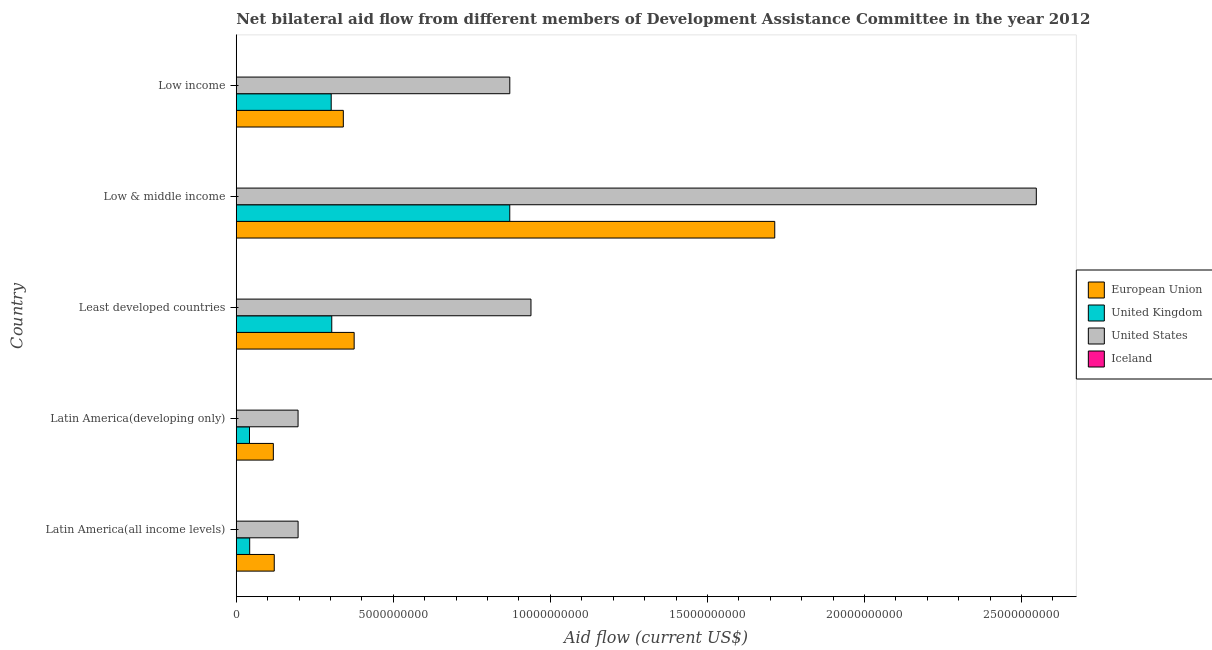How many different coloured bars are there?
Your answer should be very brief. 4. How many groups of bars are there?
Make the answer very short. 5. What is the label of the 4th group of bars from the top?
Provide a succinct answer. Latin America(developing only). In how many cases, is the number of bars for a given country not equal to the number of legend labels?
Give a very brief answer. 0. What is the amount of aid given by eu in Low income?
Make the answer very short. 3.41e+09. Across all countries, what is the maximum amount of aid given by iceland?
Offer a terse response. 2.04e+06. Across all countries, what is the minimum amount of aid given by us?
Keep it short and to the point. 1.97e+09. In which country was the amount of aid given by us maximum?
Your response must be concise. Low & middle income. In which country was the amount of aid given by us minimum?
Provide a succinct answer. Latin America(developing only). What is the total amount of aid given by eu in the graph?
Make the answer very short. 2.67e+1. What is the difference between the amount of aid given by uk in Latin America(developing only) and that in Least developed countries?
Provide a succinct answer. -2.62e+09. What is the difference between the amount of aid given by iceland in Latin America(all income levels) and the amount of aid given by us in Low income?
Your response must be concise. -8.71e+09. What is the average amount of aid given by iceland per country?
Your answer should be compact. 9.96e+05. What is the difference between the amount of aid given by iceland and amount of aid given by us in Low & middle income?
Keep it short and to the point. -2.55e+1. What is the ratio of the amount of aid given by us in Low & middle income to that in Low income?
Make the answer very short. 2.92. Is the difference between the amount of aid given by us in Latin America(developing only) and Least developed countries greater than the difference between the amount of aid given by eu in Latin America(developing only) and Least developed countries?
Provide a short and direct response. No. What is the difference between the highest and the second highest amount of aid given by uk?
Your response must be concise. 5.67e+09. What is the difference between the highest and the lowest amount of aid given by iceland?
Make the answer very short. 1.94e+06. What does the 1st bar from the top in Least developed countries represents?
Your response must be concise. Iceland. How many bars are there?
Offer a terse response. 20. Are all the bars in the graph horizontal?
Your answer should be very brief. Yes. What is the difference between two consecutive major ticks on the X-axis?
Provide a succinct answer. 5.00e+09. How many legend labels are there?
Your answer should be very brief. 4. What is the title of the graph?
Offer a very short reply. Net bilateral aid flow from different members of Development Assistance Committee in the year 2012. What is the label or title of the X-axis?
Provide a succinct answer. Aid flow (current US$). What is the Aid flow (current US$) of European Union in Latin America(all income levels)?
Your answer should be compact. 1.21e+09. What is the Aid flow (current US$) of United Kingdom in Latin America(all income levels)?
Your response must be concise. 4.28e+08. What is the Aid flow (current US$) in United States in Latin America(all income levels)?
Provide a succinct answer. 1.97e+09. What is the Aid flow (current US$) of Iceland in Latin America(all income levels)?
Offer a terse response. 1.37e+06. What is the Aid flow (current US$) of European Union in Latin America(developing only)?
Ensure brevity in your answer.  1.18e+09. What is the Aid flow (current US$) of United Kingdom in Latin America(developing only)?
Keep it short and to the point. 4.22e+08. What is the Aid flow (current US$) of United States in Latin America(developing only)?
Give a very brief answer. 1.97e+09. What is the Aid flow (current US$) in Iceland in Latin America(developing only)?
Offer a very short reply. 1.37e+06. What is the Aid flow (current US$) of European Union in Least developed countries?
Give a very brief answer. 3.75e+09. What is the Aid flow (current US$) of United Kingdom in Least developed countries?
Give a very brief answer. 3.04e+09. What is the Aid flow (current US$) in United States in Least developed countries?
Keep it short and to the point. 9.38e+09. What is the Aid flow (current US$) of Iceland in Least developed countries?
Make the answer very short. 2.04e+06. What is the Aid flow (current US$) of European Union in Low & middle income?
Keep it short and to the point. 1.71e+1. What is the Aid flow (current US$) of United Kingdom in Low & middle income?
Your answer should be very brief. 8.71e+09. What is the Aid flow (current US$) of United States in Low & middle income?
Ensure brevity in your answer.  2.55e+1. What is the Aid flow (current US$) of Iceland in Low & middle income?
Ensure brevity in your answer.  1.00e+05. What is the Aid flow (current US$) in European Union in Low income?
Offer a very short reply. 3.41e+09. What is the Aid flow (current US$) in United Kingdom in Low income?
Provide a succinct answer. 3.02e+09. What is the Aid flow (current US$) of United States in Low income?
Ensure brevity in your answer.  8.71e+09. Across all countries, what is the maximum Aid flow (current US$) in European Union?
Provide a short and direct response. 1.71e+1. Across all countries, what is the maximum Aid flow (current US$) in United Kingdom?
Keep it short and to the point. 8.71e+09. Across all countries, what is the maximum Aid flow (current US$) of United States?
Your response must be concise. 2.55e+1. Across all countries, what is the maximum Aid flow (current US$) in Iceland?
Provide a short and direct response. 2.04e+06. Across all countries, what is the minimum Aid flow (current US$) in European Union?
Offer a terse response. 1.18e+09. Across all countries, what is the minimum Aid flow (current US$) of United Kingdom?
Ensure brevity in your answer.  4.22e+08. Across all countries, what is the minimum Aid flow (current US$) in United States?
Ensure brevity in your answer.  1.97e+09. Across all countries, what is the minimum Aid flow (current US$) in Iceland?
Your response must be concise. 1.00e+05. What is the total Aid flow (current US$) in European Union in the graph?
Keep it short and to the point. 2.67e+1. What is the total Aid flow (current US$) of United Kingdom in the graph?
Make the answer very short. 1.56e+1. What is the total Aid flow (current US$) of United States in the graph?
Offer a terse response. 4.75e+1. What is the total Aid flow (current US$) in Iceland in the graph?
Ensure brevity in your answer.  4.98e+06. What is the difference between the Aid flow (current US$) in European Union in Latin America(all income levels) and that in Latin America(developing only)?
Your response must be concise. 2.92e+07. What is the difference between the Aid flow (current US$) of United Kingdom in Latin America(all income levels) and that in Latin America(developing only)?
Your answer should be compact. 5.89e+06. What is the difference between the Aid flow (current US$) in United States in Latin America(all income levels) and that in Latin America(developing only)?
Offer a terse response. 1.03e+06. What is the difference between the Aid flow (current US$) of European Union in Latin America(all income levels) and that in Least developed countries?
Your answer should be compact. -2.54e+09. What is the difference between the Aid flow (current US$) of United Kingdom in Latin America(all income levels) and that in Least developed countries?
Offer a very short reply. -2.61e+09. What is the difference between the Aid flow (current US$) of United States in Latin America(all income levels) and that in Least developed countries?
Your answer should be very brief. -7.41e+09. What is the difference between the Aid flow (current US$) of Iceland in Latin America(all income levels) and that in Least developed countries?
Keep it short and to the point. -6.70e+05. What is the difference between the Aid flow (current US$) in European Union in Latin America(all income levels) and that in Low & middle income?
Keep it short and to the point. -1.59e+1. What is the difference between the Aid flow (current US$) of United Kingdom in Latin America(all income levels) and that in Low & middle income?
Give a very brief answer. -8.28e+09. What is the difference between the Aid flow (current US$) in United States in Latin America(all income levels) and that in Low & middle income?
Give a very brief answer. -2.35e+1. What is the difference between the Aid flow (current US$) of Iceland in Latin America(all income levels) and that in Low & middle income?
Your response must be concise. 1.27e+06. What is the difference between the Aid flow (current US$) of European Union in Latin America(all income levels) and that in Low income?
Offer a very short reply. -2.20e+09. What is the difference between the Aid flow (current US$) in United Kingdom in Latin America(all income levels) and that in Low income?
Offer a terse response. -2.60e+09. What is the difference between the Aid flow (current US$) in United States in Latin America(all income levels) and that in Low income?
Provide a succinct answer. -6.74e+09. What is the difference between the Aid flow (current US$) in Iceland in Latin America(all income levels) and that in Low income?
Provide a short and direct response. 1.27e+06. What is the difference between the Aid flow (current US$) in European Union in Latin America(developing only) and that in Least developed countries?
Keep it short and to the point. -2.57e+09. What is the difference between the Aid flow (current US$) in United Kingdom in Latin America(developing only) and that in Least developed countries?
Your answer should be compact. -2.62e+09. What is the difference between the Aid flow (current US$) in United States in Latin America(developing only) and that in Least developed countries?
Make the answer very short. -7.41e+09. What is the difference between the Aid flow (current US$) in Iceland in Latin America(developing only) and that in Least developed countries?
Your answer should be very brief. -6.70e+05. What is the difference between the Aid flow (current US$) of European Union in Latin America(developing only) and that in Low & middle income?
Provide a short and direct response. -1.60e+1. What is the difference between the Aid flow (current US$) of United Kingdom in Latin America(developing only) and that in Low & middle income?
Your response must be concise. -8.29e+09. What is the difference between the Aid flow (current US$) in United States in Latin America(developing only) and that in Low & middle income?
Provide a succinct answer. -2.35e+1. What is the difference between the Aid flow (current US$) of Iceland in Latin America(developing only) and that in Low & middle income?
Your answer should be very brief. 1.27e+06. What is the difference between the Aid flow (current US$) of European Union in Latin America(developing only) and that in Low income?
Your answer should be very brief. -2.23e+09. What is the difference between the Aid flow (current US$) in United Kingdom in Latin America(developing only) and that in Low income?
Offer a very short reply. -2.60e+09. What is the difference between the Aid flow (current US$) of United States in Latin America(developing only) and that in Low income?
Offer a very short reply. -6.74e+09. What is the difference between the Aid flow (current US$) in Iceland in Latin America(developing only) and that in Low income?
Provide a short and direct response. 1.27e+06. What is the difference between the Aid flow (current US$) of European Union in Least developed countries and that in Low & middle income?
Your answer should be compact. -1.34e+1. What is the difference between the Aid flow (current US$) in United Kingdom in Least developed countries and that in Low & middle income?
Ensure brevity in your answer.  -5.67e+09. What is the difference between the Aid flow (current US$) of United States in Least developed countries and that in Low & middle income?
Make the answer very short. -1.61e+1. What is the difference between the Aid flow (current US$) in Iceland in Least developed countries and that in Low & middle income?
Make the answer very short. 1.94e+06. What is the difference between the Aid flow (current US$) in European Union in Least developed countries and that in Low income?
Ensure brevity in your answer.  3.45e+08. What is the difference between the Aid flow (current US$) of United Kingdom in Least developed countries and that in Low income?
Offer a terse response. 1.79e+07. What is the difference between the Aid flow (current US$) of United States in Least developed countries and that in Low income?
Your answer should be compact. 6.74e+08. What is the difference between the Aid flow (current US$) of Iceland in Least developed countries and that in Low income?
Your answer should be very brief. 1.94e+06. What is the difference between the Aid flow (current US$) in European Union in Low & middle income and that in Low income?
Your response must be concise. 1.37e+1. What is the difference between the Aid flow (current US$) in United Kingdom in Low & middle income and that in Low income?
Make the answer very short. 5.68e+09. What is the difference between the Aid flow (current US$) of United States in Low & middle income and that in Low income?
Provide a succinct answer. 1.68e+1. What is the difference between the Aid flow (current US$) of Iceland in Low & middle income and that in Low income?
Give a very brief answer. 0. What is the difference between the Aid flow (current US$) in European Union in Latin America(all income levels) and the Aid flow (current US$) in United Kingdom in Latin America(developing only)?
Offer a terse response. 7.88e+08. What is the difference between the Aid flow (current US$) of European Union in Latin America(all income levels) and the Aid flow (current US$) of United States in Latin America(developing only)?
Ensure brevity in your answer.  -7.58e+08. What is the difference between the Aid flow (current US$) of European Union in Latin America(all income levels) and the Aid flow (current US$) of Iceland in Latin America(developing only)?
Give a very brief answer. 1.21e+09. What is the difference between the Aid flow (current US$) in United Kingdom in Latin America(all income levels) and the Aid flow (current US$) in United States in Latin America(developing only)?
Offer a terse response. -1.54e+09. What is the difference between the Aid flow (current US$) in United Kingdom in Latin America(all income levels) and the Aid flow (current US$) in Iceland in Latin America(developing only)?
Give a very brief answer. 4.26e+08. What is the difference between the Aid flow (current US$) of United States in Latin America(all income levels) and the Aid flow (current US$) of Iceland in Latin America(developing only)?
Make the answer very short. 1.97e+09. What is the difference between the Aid flow (current US$) in European Union in Latin America(all income levels) and the Aid flow (current US$) in United Kingdom in Least developed countries?
Offer a terse response. -1.83e+09. What is the difference between the Aid flow (current US$) of European Union in Latin America(all income levels) and the Aid flow (current US$) of United States in Least developed countries?
Your answer should be compact. -8.17e+09. What is the difference between the Aid flow (current US$) in European Union in Latin America(all income levels) and the Aid flow (current US$) in Iceland in Least developed countries?
Ensure brevity in your answer.  1.21e+09. What is the difference between the Aid flow (current US$) of United Kingdom in Latin America(all income levels) and the Aid flow (current US$) of United States in Least developed countries?
Keep it short and to the point. -8.95e+09. What is the difference between the Aid flow (current US$) in United Kingdom in Latin America(all income levels) and the Aid flow (current US$) in Iceland in Least developed countries?
Offer a very short reply. 4.26e+08. What is the difference between the Aid flow (current US$) in United States in Latin America(all income levels) and the Aid flow (current US$) in Iceland in Least developed countries?
Your response must be concise. 1.97e+09. What is the difference between the Aid flow (current US$) in European Union in Latin America(all income levels) and the Aid flow (current US$) in United Kingdom in Low & middle income?
Ensure brevity in your answer.  -7.50e+09. What is the difference between the Aid flow (current US$) of European Union in Latin America(all income levels) and the Aid flow (current US$) of United States in Low & middle income?
Offer a terse response. -2.43e+1. What is the difference between the Aid flow (current US$) in European Union in Latin America(all income levels) and the Aid flow (current US$) in Iceland in Low & middle income?
Give a very brief answer. 1.21e+09. What is the difference between the Aid flow (current US$) in United Kingdom in Latin America(all income levels) and the Aid flow (current US$) in United States in Low & middle income?
Keep it short and to the point. -2.50e+1. What is the difference between the Aid flow (current US$) in United Kingdom in Latin America(all income levels) and the Aid flow (current US$) in Iceland in Low & middle income?
Make the answer very short. 4.27e+08. What is the difference between the Aid flow (current US$) in United States in Latin America(all income levels) and the Aid flow (current US$) in Iceland in Low & middle income?
Keep it short and to the point. 1.97e+09. What is the difference between the Aid flow (current US$) in European Union in Latin America(all income levels) and the Aid flow (current US$) in United Kingdom in Low income?
Your answer should be compact. -1.81e+09. What is the difference between the Aid flow (current US$) of European Union in Latin America(all income levels) and the Aid flow (current US$) of United States in Low income?
Give a very brief answer. -7.50e+09. What is the difference between the Aid flow (current US$) in European Union in Latin America(all income levels) and the Aid flow (current US$) in Iceland in Low income?
Offer a very short reply. 1.21e+09. What is the difference between the Aid flow (current US$) of United Kingdom in Latin America(all income levels) and the Aid flow (current US$) of United States in Low income?
Offer a very short reply. -8.28e+09. What is the difference between the Aid flow (current US$) in United Kingdom in Latin America(all income levels) and the Aid flow (current US$) in Iceland in Low income?
Your response must be concise. 4.27e+08. What is the difference between the Aid flow (current US$) in United States in Latin America(all income levels) and the Aid flow (current US$) in Iceland in Low income?
Keep it short and to the point. 1.97e+09. What is the difference between the Aid flow (current US$) of European Union in Latin America(developing only) and the Aid flow (current US$) of United Kingdom in Least developed countries?
Ensure brevity in your answer.  -1.86e+09. What is the difference between the Aid flow (current US$) in European Union in Latin America(developing only) and the Aid flow (current US$) in United States in Least developed countries?
Provide a short and direct response. -8.20e+09. What is the difference between the Aid flow (current US$) of European Union in Latin America(developing only) and the Aid flow (current US$) of Iceland in Least developed countries?
Make the answer very short. 1.18e+09. What is the difference between the Aid flow (current US$) of United Kingdom in Latin America(developing only) and the Aid flow (current US$) of United States in Least developed countries?
Make the answer very short. -8.96e+09. What is the difference between the Aid flow (current US$) of United Kingdom in Latin America(developing only) and the Aid flow (current US$) of Iceland in Least developed countries?
Provide a succinct answer. 4.20e+08. What is the difference between the Aid flow (current US$) of United States in Latin America(developing only) and the Aid flow (current US$) of Iceland in Least developed countries?
Your answer should be compact. 1.97e+09. What is the difference between the Aid flow (current US$) in European Union in Latin America(developing only) and the Aid flow (current US$) in United Kingdom in Low & middle income?
Your answer should be very brief. -7.53e+09. What is the difference between the Aid flow (current US$) in European Union in Latin America(developing only) and the Aid flow (current US$) in United States in Low & middle income?
Give a very brief answer. -2.43e+1. What is the difference between the Aid flow (current US$) in European Union in Latin America(developing only) and the Aid flow (current US$) in Iceland in Low & middle income?
Offer a very short reply. 1.18e+09. What is the difference between the Aid flow (current US$) of United Kingdom in Latin America(developing only) and the Aid flow (current US$) of United States in Low & middle income?
Offer a very short reply. -2.50e+1. What is the difference between the Aid flow (current US$) of United Kingdom in Latin America(developing only) and the Aid flow (current US$) of Iceland in Low & middle income?
Offer a terse response. 4.22e+08. What is the difference between the Aid flow (current US$) of United States in Latin America(developing only) and the Aid flow (current US$) of Iceland in Low & middle income?
Offer a very short reply. 1.97e+09. What is the difference between the Aid flow (current US$) in European Union in Latin America(developing only) and the Aid flow (current US$) in United Kingdom in Low income?
Your response must be concise. -1.84e+09. What is the difference between the Aid flow (current US$) in European Union in Latin America(developing only) and the Aid flow (current US$) in United States in Low income?
Provide a succinct answer. -7.53e+09. What is the difference between the Aid flow (current US$) of European Union in Latin America(developing only) and the Aid flow (current US$) of Iceland in Low income?
Provide a succinct answer. 1.18e+09. What is the difference between the Aid flow (current US$) of United Kingdom in Latin America(developing only) and the Aid flow (current US$) of United States in Low income?
Keep it short and to the point. -8.29e+09. What is the difference between the Aid flow (current US$) in United Kingdom in Latin America(developing only) and the Aid flow (current US$) in Iceland in Low income?
Your response must be concise. 4.22e+08. What is the difference between the Aid flow (current US$) in United States in Latin America(developing only) and the Aid flow (current US$) in Iceland in Low income?
Offer a very short reply. 1.97e+09. What is the difference between the Aid flow (current US$) of European Union in Least developed countries and the Aid flow (current US$) of United Kingdom in Low & middle income?
Ensure brevity in your answer.  -4.95e+09. What is the difference between the Aid flow (current US$) of European Union in Least developed countries and the Aid flow (current US$) of United States in Low & middle income?
Give a very brief answer. -2.17e+1. What is the difference between the Aid flow (current US$) of European Union in Least developed countries and the Aid flow (current US$) of Iceland in Low & middle income?
Make the answer very short. 3.75e+09. What is the difference between the Aid flow (current US$) of United Kingdom in Least developed countries and the Aid flow (current US$) of United States in Low & middle income?
Your response must be concise. -2.24e+1. What is the difference between the Aid flow (current US$) in United Kingdom in Least developed countries and the Aid flow (current US$) in Iceland in Low & middle income?
Provide a succinct answer. 3.04e+09. What is the difference between the Aid flow (current US$) in United States in Least developed countries and the Aid flow (current US$) in Iceland in Low & middle income?
Your answer should be very brief. 9.38e+09. What is the difference between the Aid flow (current US$) in European Union in Least developed countries and the Aid flow (current US$) in United Kingdom in Low income?
Keep it short and to the point. 7.31e+08. What is the difference between the Aid flow (current US$) in European Union in Least developed countries and the Aid flow (current US$) in United States in Low income?
Your answer should be compact. -4.95e+09. What is the difference between the Aid flow (current US$) in European Union in Least developed countries and the Aid flow (current US$) in Iceland in Low income?
Provide a short and direct response. 3.75e+09. What is the difference between the Aid flow (current US$) of United Kingdom in Least developed countries and the Aid flow (current US$) of United States in Low income?
Ensure brevity in your answer.  -5.67e+09. What is the difference between the Aid flow (current US$) in United Kingdom in Least developed countries and the Aid flow (current US$) in Iceland in Low income?
Offer a terse response. 3.04e+09. What is the difference between the Aid flow (current US$) in United States in Least developed countries and the Aid flow (current US$) in Iceland in Low income?
Provide a short and direct response. 9.38e+09. What is the difference between the Aid flow (current US$) in European Union in Low & middle income and the Aid flow (current US$) in United Kingdom in Low income?
Offer a terse response. 1.41e+1. What is the difference between the Aid flow (current US$) of European Union in Low & middle income and the Aid flow (current US$) of United States in Low income?
Your response must be concise. 8.43e+09. What is the difference between the Aid flow (current US$) in European Union in Low & middle income and the Aid flow (current US$) in Iceland in Low income?
Provide a short and direct response. 1.71e+1. What is the difference between the Aid flow (current US$) of United Kingdom in Low & middle income and the Aid flow (current US$) of United States in Low income?
Give a very brief answer. -1.13e+06. What is the difference between the Aid flow (current US$) in United Kingdom in Low & middle income and the Aid flow (current US$) in Iceland in Low income?
Make the answer very short. 8.71e+09. What is the difference between the Aid flow (current US$) of United States in Low & middle income and the Aid flow (current US$) of Iceland in Low income?
Keep it short and to the point. 2.55e+1. What is the average Aid flow (current US$) in European Union per country?
Give a very brief answer. 5.34e+09. What is the average Aid flow (current US$) in United Kingdom per country?
Provide a succinct answer. 3.12e+09. What is the average Aid flow (current US$) in United States per country?
Offer a very short reply. 9.50e+09. What is the average Aid flow (current US$) of Iceland per country?
Offer a very short reply. 9.96e+05. What is the difference between the Aid flow (current US$) of European Union and Aid flow (current US$) of United Kingdom in Latin America(all income levels)?
Your answer should be compact. 7.82e+08. What is the difference between the Aid flow (current US$) in European Union and Aid flow (current US$) in United States in Latin America(all income levels)?
Ensure brevity in your answer.  -7.59e+08. What is the difference between the Aid flow (current US$) of European Union and Aid flow (current US$) of Iceland in Latin America(all income levels)?
Offer a terse response. 1.21e+09. What is the difference between the Aid flow (current US$) in United Kingdom and Aid flow (current US$) in United States in Latin America(all income levels)?
Offer a terse response. -1.54e+09. What is the difference between the Aid flow (current US$) of United Kingdom and Aid flow (current US$) of Iceland in Latin America(all income levels)?
Offer a terse response. 4.26e+08. What is the difference between the Aid flow (current US$) in United States and Aid flow (current US$) in Iceland in Latin America(all income levels)?
Keep it short and to the point. 1.97e+09. What is the difference between the Aid flow (current US$) in European Union and Aid flow (current US$) in United Kingdom in Latin America(developing only)?
Provide a succinct answer. 7.59e+08. What is the difference between the Aid flow (current US$) in European Union and Aid flow (current US$) in United States in Latin America(developing only)?
Provide a succinct answer. -7.87e+08. What is the difference between the Aid flow (current US$) of European Union and Aid flow (current US$) of Iceland in Latin America(developing only)?
Provide a short and direct response. 1.18e+09. What is the difference between the Aid flow (current US$) in United Kingdom and Aid flow (current US$) in United States in Latin America(developing only)?
Your response must be concise. -1.55e+09. What is the difference between the Aid flow (current US$) of United Kingdom and Aid flow (current US$) of Iceland in Latin America(developing only)?
Your response must be concise. 4.20e+08. What is the difference between the Aid flow (current US$) of United States and Aid flow (current US$) of Iceland in Latin America(developing only)?
Ensure brevity in your answer.  1.97e+09. What is the difference between the Aid flow (current US$) of European Union and Aid flow (current US$) of United Kingdom in Least developed countries?
Offer a very short reply. 7.13e+08. What is the difference between the Aid flow (current US$) of European Union and Aid flow (current US$) of United States in Least developed countries?
Provide a succinct answer. -5.63e+09. What is the difference between the Aid flow (current US$) of European Union and Aid flow (current US$) of Iceland in Least developed countries?
Provide a short and direct response. 3.75e+09. What is the difference between the Aid flow (current US$) of United Kingdom and Aid flow (current US$) of United States in Least developed countries?
Give a very brief answer. -6.34e+09. What is the difference between the Aid flow (current US$) in United Kingdom and Aid flow (current US$) in Iceland in Least developed countries?
Offer a terse response. 3.04e+09. What is the difference between the Aid flow (current US$) of United States and Aid flow (current US$) of Iceland in Least developed countries?
Provide a short and direct response. 9.38e+09. What is the difference between the Aid flow (current US$) of European Union and Aid flow (current US$) of United Kingdom in Low & middle income?
Offer a very short reply. 8.44e+09. What is the difference between the Aid flow (current US$) of European Union and Aid flow (current US$) of United States in Low & middle income?
Provide a short and direct response. -8.33e+09. What is the difference between the Aid flow (current US$) in European Union and Aid flow (current US$) in Iceland in Low & middle income?
Offer a terse response. 1.71e+1. What is the difference between the Aid flow (current US$) in United Kingdom and Aid flow (current US$) in United States in Low & middle income?
Keep it short and to the point. -1.68e+1. What is the difference between the Aid flow (current US$) in United Kingdom and Aid flow (current US$) in Iceland in Low & middle income?
Your response must be concise. 8.71e+09. What is the difference between the Aid flow (current US$) of United States and Aid flow (current US$) of Iceland in Low & middle income?
Offer a very short reply. 2.55e+1. What is the difference between the Aid flow (current US$) of European Union and Aid flow (current US$) of United Kingdom in Low income?
Your answer should be compact. 3.86e+08. What is the difference between the Aid flow (current US$) of European Union and Aid flow (current US$) of United States in Low income?
Provide a succinct answer. -5.30e+09. What is the difference between the Aid flow (current US$) in European Union and Aid flow (current US$) in Iceland in Low income?
Your answer should be compact. 3.41e+09. What is the difference between the Aid flow (current US$) in United Kingdom and Aid flow (current US$) in United States in Low income?
Make the answer very short. -5.69e+09. What is the difference between the Aid flow (current US$) of United Kingdom and Aid flow (current US$) of Iceland in Low income?
Provide a short and direct response. 3.02e+09. What is the difference between the Aid flow (current US$) in United States and Aid flow (current US$) in Iceland in Low income?
Offer a very short reply. 8.71e+09. What is the ratio of the Aid flow (current US$) in European Union in Latin America(all income levels) to that in Latin America(developing only)?
Your response must be concise. 1.02. What is the ratio of the Aid flow (current US$) in United Kingdom in Latin America(all income levels) to that in Latin America(developing only)?
Keep it short and to the point. 1.01. What is the ratio of the Aid flow (current US$) in United States in Latin America(all income levels) to that in Latin America(developing only)?
Give a very brief answer. 1. What is the ratio of the Aid flow (current US$) in Iceland in Latin America(all income levels) to that in Latin America(developing only)?
Your response must be concise. 1. What is the ratio of the Aid flow (current US$) in European Union in Latin America(all income levels) to that in Least developed countries?
Your answer should be very brief. 0.32. What is the ratio of the Aid flow (current US$) of United Kingdom in Latin America(all income levels) to that in Least developed countries?
Provide a short and direct response. 0.14. What is the ratio of the Aid flow (current US$) of United States in Latin America(all income levels) to that in Least developed countries?
Make the answer very short. 0.21. What is the ratio of the Aid flow (current US$) of Iceland in Latin America(all income levels) to that in Least developed countries?
Offer a very short reply. 0.67. What is the ratio of the Aid flow (current US$) of European Union in Latin America(all income levels) to that in Low & middle income?
Your answer should be very brief. 0.07. What is the ratio of the Aid flow (current US$) in United Kingdom in Latin America(all income levels) to that in Low & middle income?
Your answer should be very brief. 0.05. What is the ratio of the Aid flow (current US$) of United States in Latin America(all income levels) to that in Low & middle income?
Your answer should be very brief. 0.08. What is the ratio of the Aid flow (current US$) in Iceland in Latin America(all income levels) to that in Low & middle income?
Keep it short and to the point. 13.7. What is the ratio of the Aid flow (current US$) in European Union in Latin America(all income levels) to that in Low income?
Give a very brief answer. 0.35. What is the ratio of the Aid flow (current US$) of United Kingdom in Latin America(all income levels) to that in Low income?
Provide a succinct answer. 0.14. What is the ratio of the Aid flow (current US$) of United States in Latin America(all income levels) to that in Low income?
Offer a very short reply. 0.23. What is the ratio of the Aid flow (current US$) in European Union in Latin America(developing only) to that in Least developed countries?
Give a very brief answer. 0.31. What is the ratio of the Aid flow (current US$) of United Kingdom in Latin America(developing only) to that in Least developed countries?
Your answer should be compact. 0.14. What is the ratio of the Aid flow (current US$) of United States in Latin America(developing only) to that in Least developed countries?
Provide a short and direct response. 0.21. What is the ratio of the Aid flow (current US$) of Iceland in Latin America(developing only) to that in Least developed countries?
Your answer should be very brief. 0.67. What is the ratio of the Aid flow (current US$) in European Union in Latin America(developing only) to that in Low & middle income?
Ensure brevity in your answer.  0.07. What is the ratio of the Aid flow (current US$) of United Kingdom in Latin America(developing only) to that in Low & middle income?
Offer a terse response. 0.05. What is the ratio of the Aid flow (current US$) of United States in Latin America(developing only) to that in Low & middle income?
Offer a very short reply. 0.08. What is the ratio of the Aid flow (current US$) of European Union in Latin America(developing only) to that in Low income?
Your answer should be compact. 0.35. What is the ratio of the Aid flow (current US$) of United Kingdom in Latin America(developing only) to that in Low income?
Your response must be concise. 0.14. What is the ratio of the Aid flow (current US$) of United States in Latin America(developing only) to that in Low income?
Ensure brevity in your answer.  0.23. What is the ratio of the Aid flow (current US$) in Iceland in Latin America(developing only) to that in Low income?
Offer a very short reply. 13.7. What is the ratio of the Aid flow (current US$) in European Union in Least developed countries to that in Low & middle income?
Make the answer very short. 0.22. What is the ratio of the Aid flow (current US$) of United Kingdom in Least developed countries to that in Low & middle income?
Keep it short and to the point. 0.35. What is the ratio of the Aid flow (current US$) of United States in Least developed countries to that in Low & middle income?
Offer a terse response. 0.37. What is the ratio of the Aid flow (current US$) in Iceland in Least developed countries to that in Low & middle income?
Ensure brevity in your answer.  20.4. What is the ratio of the Aid flow (current US$) in European Union in Least developed countries to that in Low income?
Your answer should be compact. 1.1. What is the ratio of the Aid flow (current US$) in United Kingdom in Least developed countries to that in Low income?
Offer a very short reply. 1.01. What is the ratio of the Aid flow (current US$) of United States in Least developed countries to that in Low income?
Ensure brevity in your answer.  1.08. What is the ratio of the Aid flow (current US$) of Iceland in Least developed countries to that in Low income?
Offer a very short reply. 20.4. What is the ratio of the Aid flow (current US$) in European Union in Low & middle income to that in Low income?
Ensure brevity in your answer.  5.03. What is the ratio of the Aid flow (current US$) of United Kingdom in Low & middle income to that in Low income?
Provide a short and direct response. 2.88. What is the ratio of the Aid flow (current US$) of United States in Low & middle income to that in Low income?
Provide a succinct answer. 2.92. What is the ratio of the Aid flow (current US$) in Iceland in Low & middle income to that in Low income?
Offer a very short reply. 1. What is the difference between the highest and the second highest Aid flow (current US$) in European Union?
Your answer should be very brief. 1.34e+1. What is the difference between the highest and the second highest Aid flow (current US$) of United Kingdom?
Offer a very short reply. 5.67e+09. What is the difference between the highest and the second highest Aid flow (current US$) of United States?
Your answer should be compact. 1.61e+1. What is the difference between the highest and the second highest Aid flow (current US$) in Iceland?
Ensure brevity in your answer.  6.70e+05. What is the difference between the highest and the lowest Aid flow (current US$) of European Union?
Keep it short and to the point. 1.60e+1. What is the difference between the highest and the lowest Aid flow (current US$) in United Kingdom?
Your response must be concise. 8.29e+09. What is the difference between the highest and the lowest Aid flow (current US$) of United States?
Provide a short and direct response. 2.35e+1. What is the difference between the highest and the lowest Aid flow (current US$) of Iceland?
Offer a terse response. 1.94e+06. 